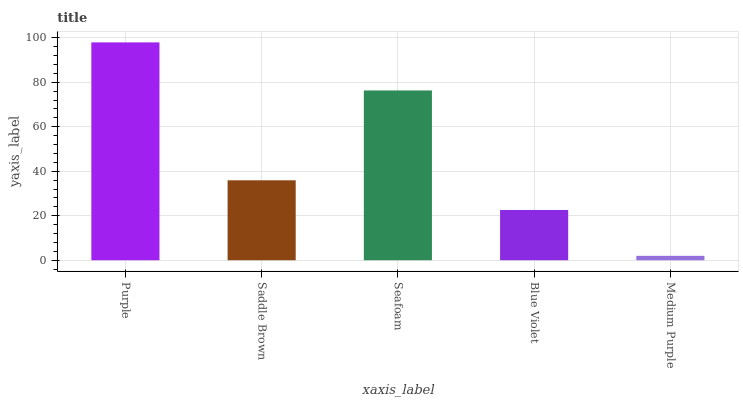Is Saddle Brown the minimum?
Answer yes or no. No. Is Saddle Brown the maximum?
Answer yes or no. No. Is Purple greater than Saddle Brown?
Answer yes or no. Yes. Is Saddle Brown less than Purple?
Answer yes or no. Yes. Is Saddle Brown greater than Purple?
Answer yes or no. No. Is Purple less than Saddle Brown?
Answer yes or no. No. Is Saddle Brown the high median?
Answer yes or no. Yes. Is Saddle Brown the low median?
Answer yes or no. Yes. Is Seafoam the high median?
Answer yes or no. No. Is Purple the low median?
Answer yes or no. No. 